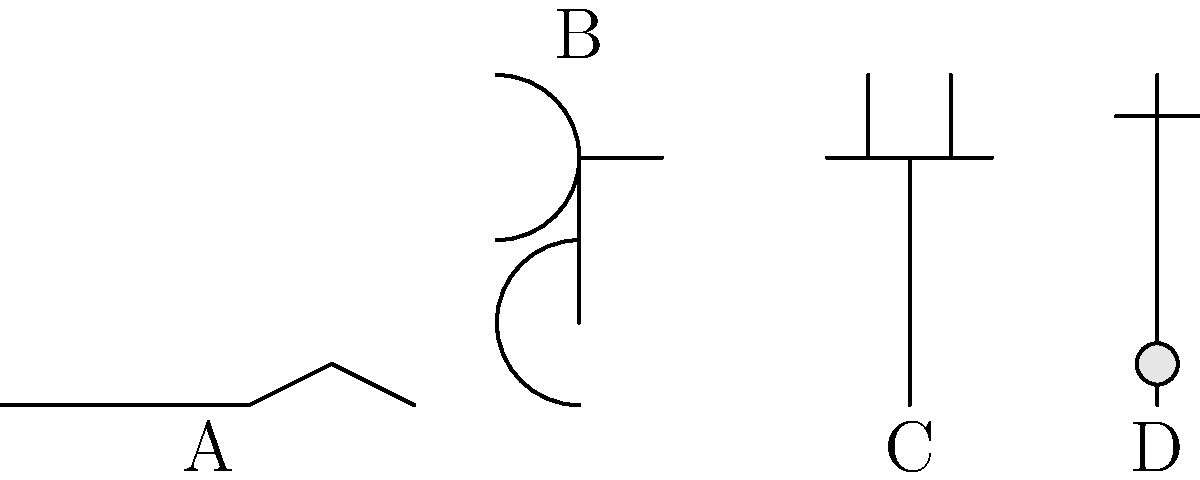Identify the medical instrument labeled 'B' in the image above. How is this instrument commonly used in healthcare settings? To answer this question, let's analyze the image and the instruments depicted:

1. Instrument A appears to be a scalpel, a surgical cutting tool.
2. Instrument B shows a curved shape at the top with two branches, connected to a long tube. This is characteristic of a stethoscope.
3. Instrument C resembles a syringe, used for injections or drawing fluids.
4. Instrument D looks like a thermometer, with a bulb at the bottom.

The question asks specifically about instrument B, which we've identified as a stethoscope. 

Stethoscopes are commonly used in healthcare settings for the following purposes:

1. Listening to heart sounds (auscultation of the heart)
2. Assessing lung sounds and detecting abnormalities in breathing
3. Listening to bowel sounds
4. Measuring blood pressure when used in conjunction with a sphygmomanometer

Healthcare professionals, including doctors and nurses, routinely use stethoscopes as a primary diagnostic tool for initial patient assessments and ongoing monitoring of various bodily functions.
Answer: Stethoscope; used for listening to heart, lung, and bowel sounds, and measuring blood pressure. 